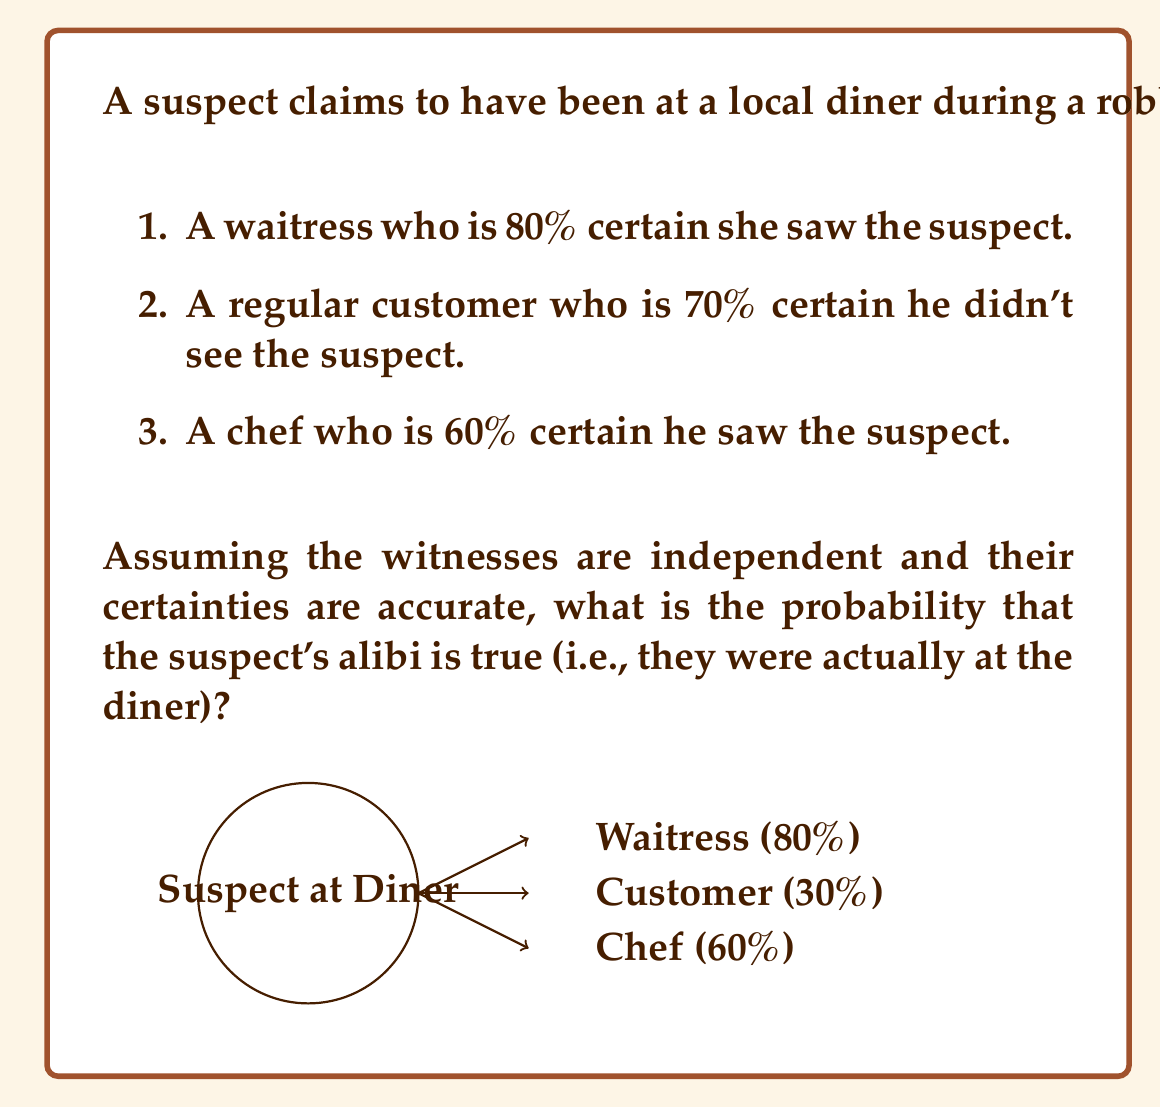Can you answer this question? Let's approach this step-by-step:

1) First, we need to calculate the probability of each witness's testimony given that the suspect was actually at the diner:

   Waitress: $P(W|D) = 0.80$
   Customer: $P(C|D) = 0.30$ (since they're 70% certain they didn't see the suspect)
   Chef: $P(H|D) = 0.60$

2) The probability of all these independent events occurring simultaneously is their product:

   $P(W \cap C \cap H | D) = P(W|D) \times P(C|D) \times P(H|D)$
   $= 0.80 \times 0.30 \times 0.60 = 0.144$

3) Now, we need to consider the opposite scenario - the probability of these testimonies if the suspect wasn't at the diner:

   Waitress: $P(W|\neg D) = 0.20$
   Customer: $P(C|\neg D) = 0.70$
   Chef: $P(H|\neg D) = 0.40$

   $P(W \cap C \cap H | \neg D) = 0.20 \times 0.70 \times 0.40 = 0.056$

4) We can now use Bayes' theorem to calculate the probability that the suspect was at the diner given the witness testimonies:

   $$P(D|W \cap C \cap H) = \frac{P(W \cap C \cap H|D) \times P(D)}{P(W \cap C \cap H|D) \times P(D) + P(W \cap C \cap H|\neg D) \times P(\neg D)}$$

5) Assuming no prior knowledge about the suspect's whereabouts, we can set $P(D) = P(\neg D) = 0.5$:

   $$P(D|W \cap C \cap H) = \frac{0.144 \times 0.5}{0.144 \times 0.5 + 0.056 \times 0.5} = \frac{0.072}{0.072 + 0.028} = \frac{0.072}{0.100} = 0.72$$

Therefore, based on the witness testimonies, there is a 72% probability that the suspect's alibi is true.
Answer: 0.72 or 72% 